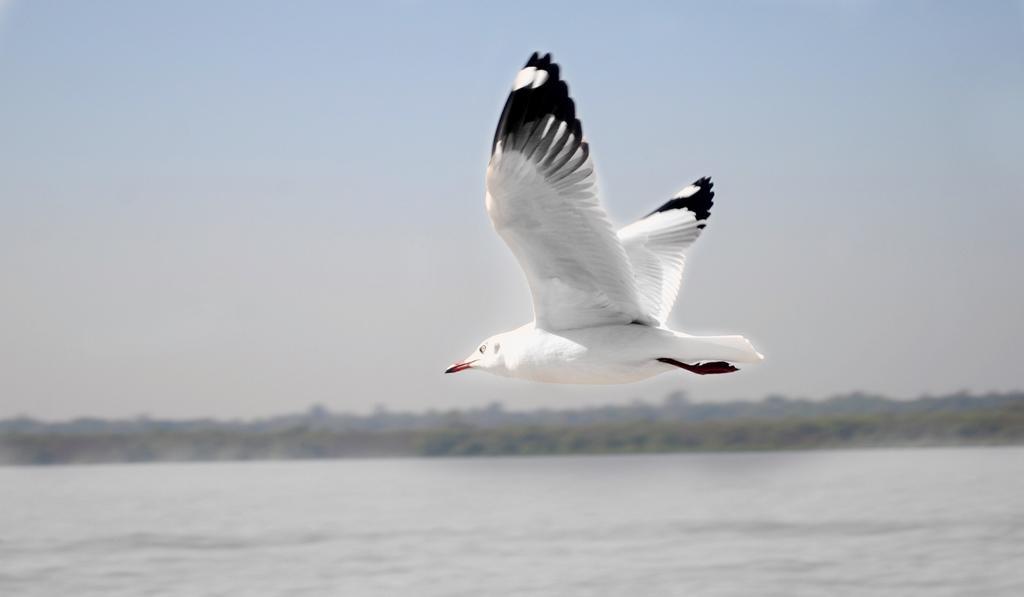Could you give a brief overview of what you see in this image? In this image there is a bird flying over the water, sky and maybe few trees. 